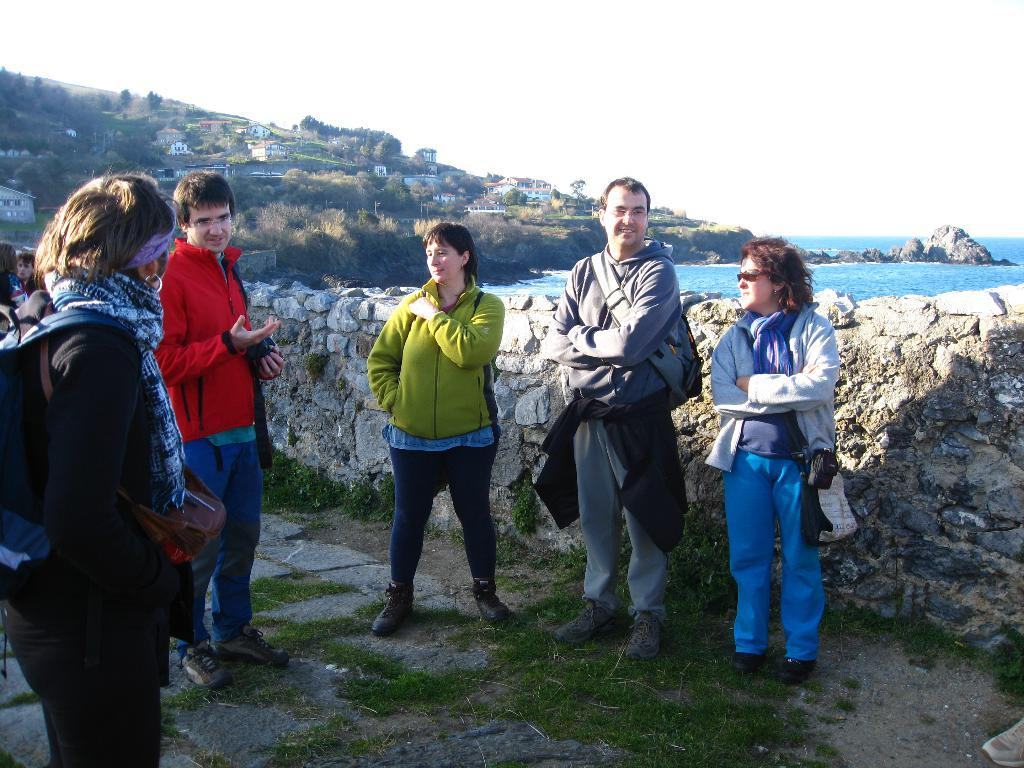What is happening in the image? There are people standing in the image. What is behind the people? There is a wall behind the people. What can be seen in the distance in the image? There are buildings, trees, a river, and the sky visible in the background of the image. Can you tell me how many snails are crawling on the wall in the image? There are no snails visible on the wall in the image. What type of cheese is being served at the birth celebration in the image? There is no birth celebration or cheese present in the image. 